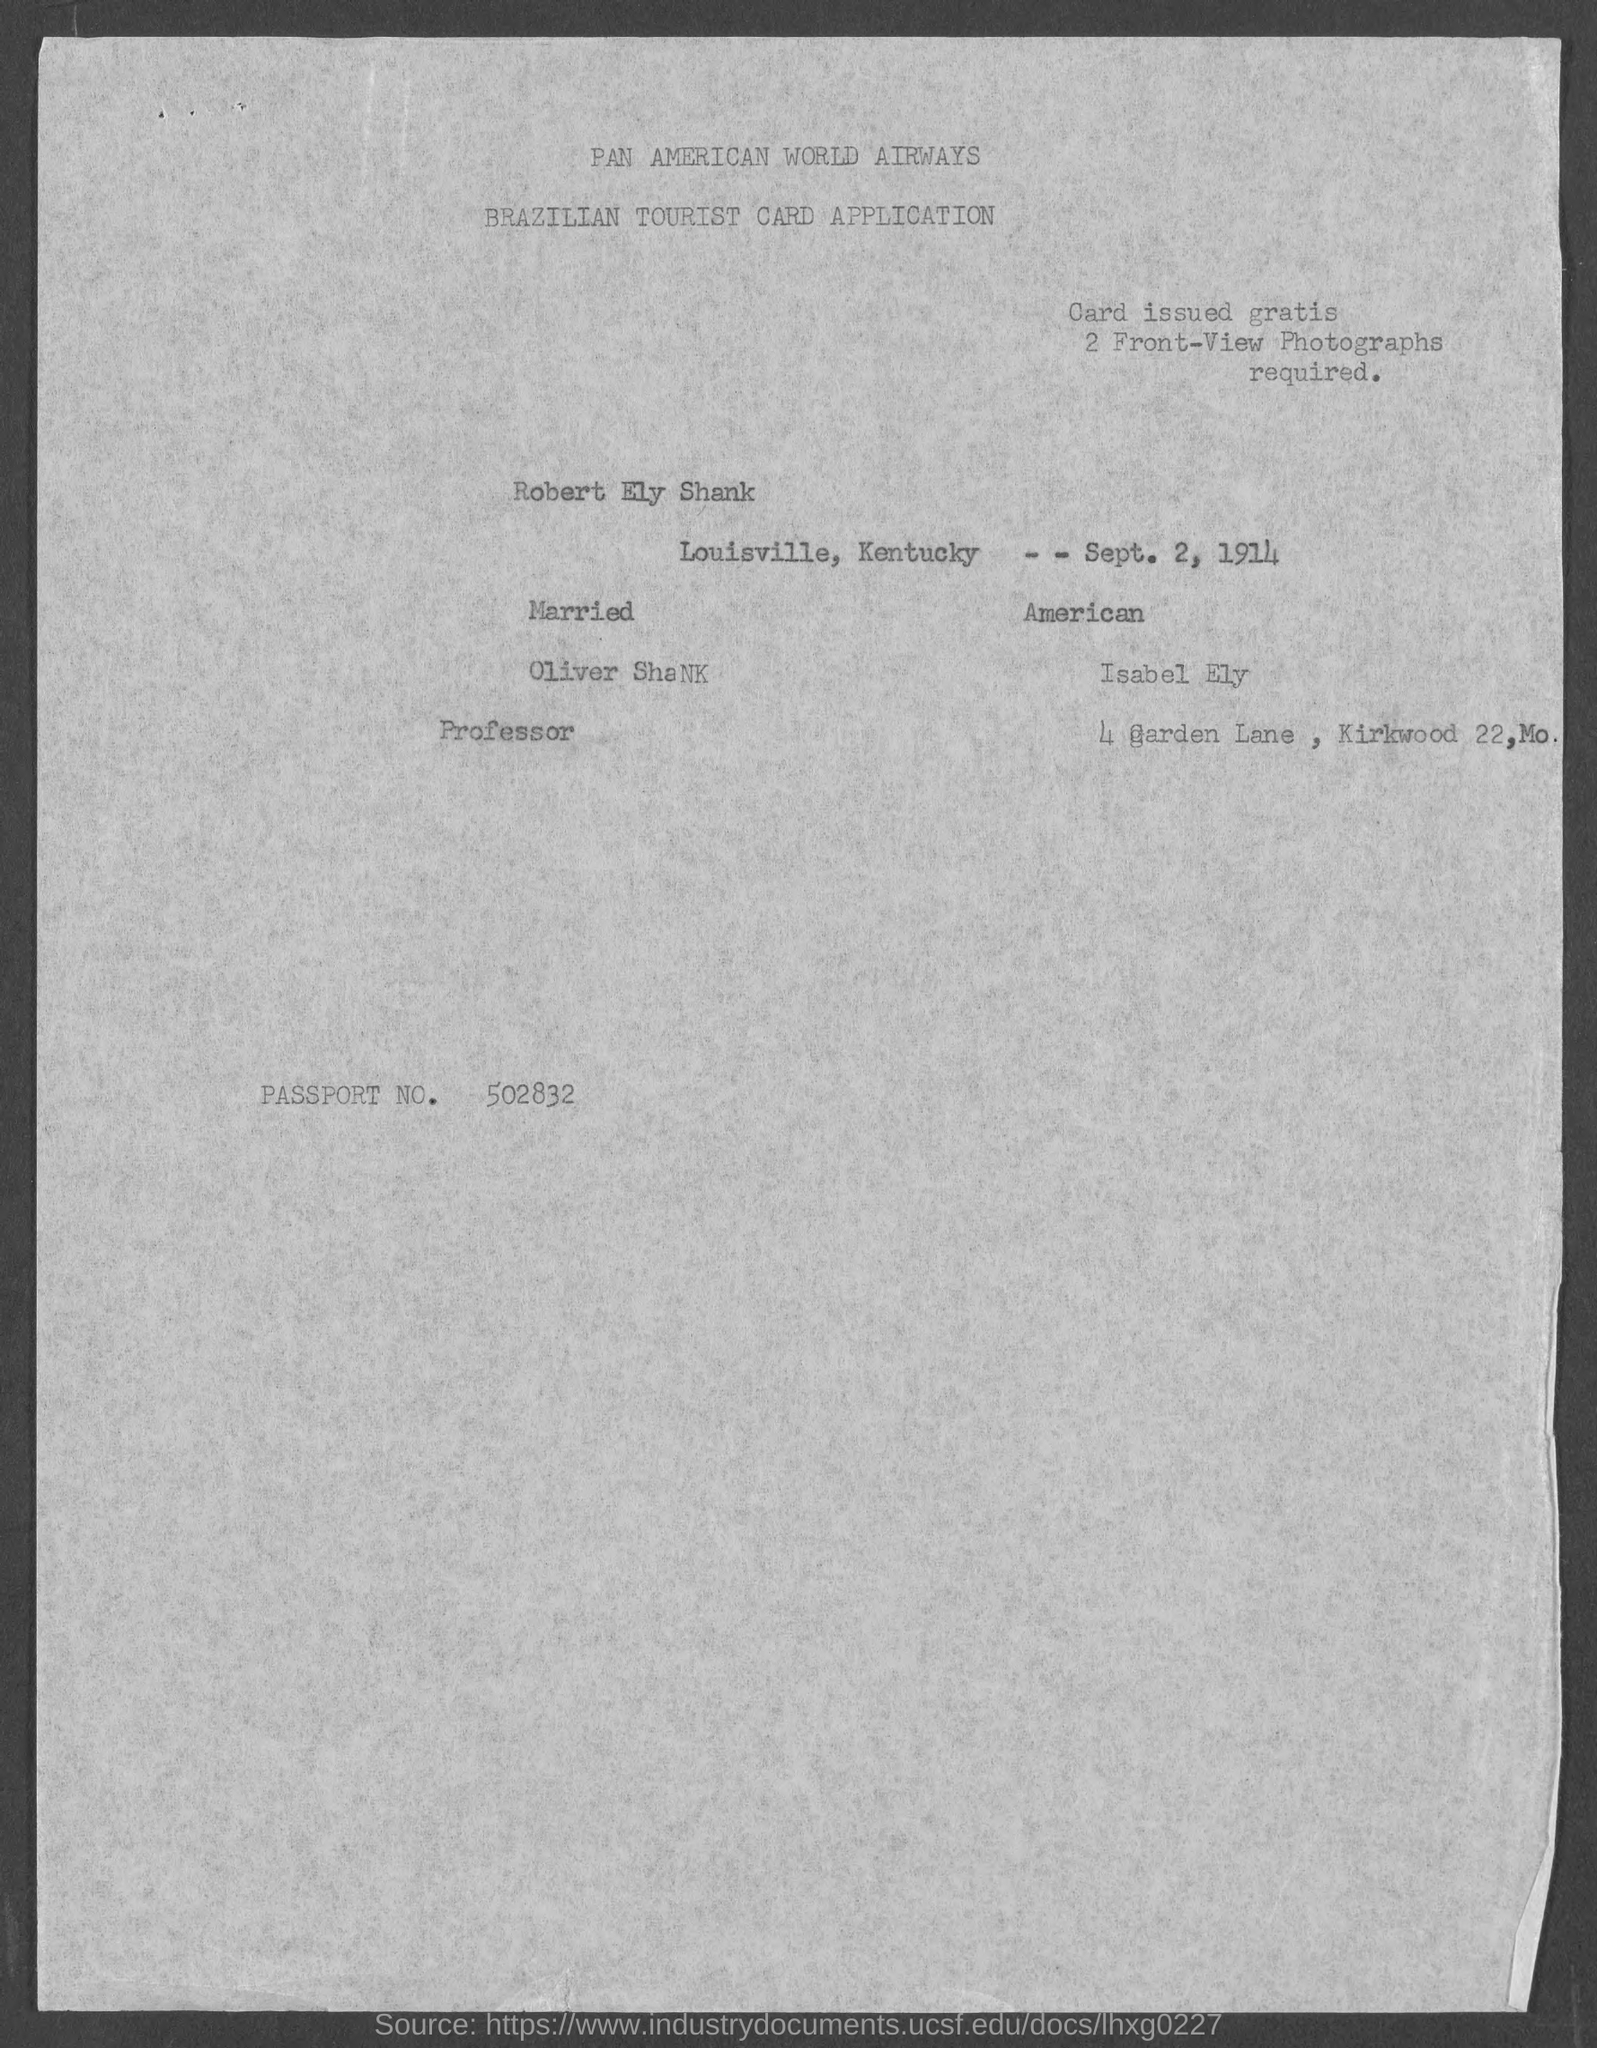What is the passport no.?
Offer a terse response. 502832. 